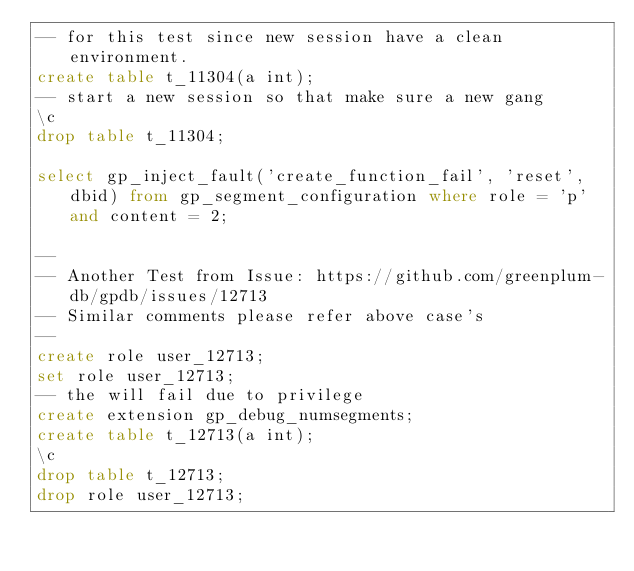<code> <loc_0><loc_0><loc_500><loc_500><_SQL_>-- for this test since new session have a clean environment.
create table t_11304(a int);
-- start a new session so that make sure a new gang
\c
drop table t_11304;

select gp_inject_fault('create_function_fail', 'reset', dbid) from gp_segment_configuration where role = 'p' and content = 2;

--
-- Another Test from Issue: https://github.com/greenplum-db/gpdb/issues/12713
-- Similar comments please refer above case's
--
create role user_12713;
set role user_12713;
-- the will fail due to privilege
create extension gp_debug_numsegments;
create table t_12713(a int);
\c
drop table t_12713;
drop role user_12713;
</code> 